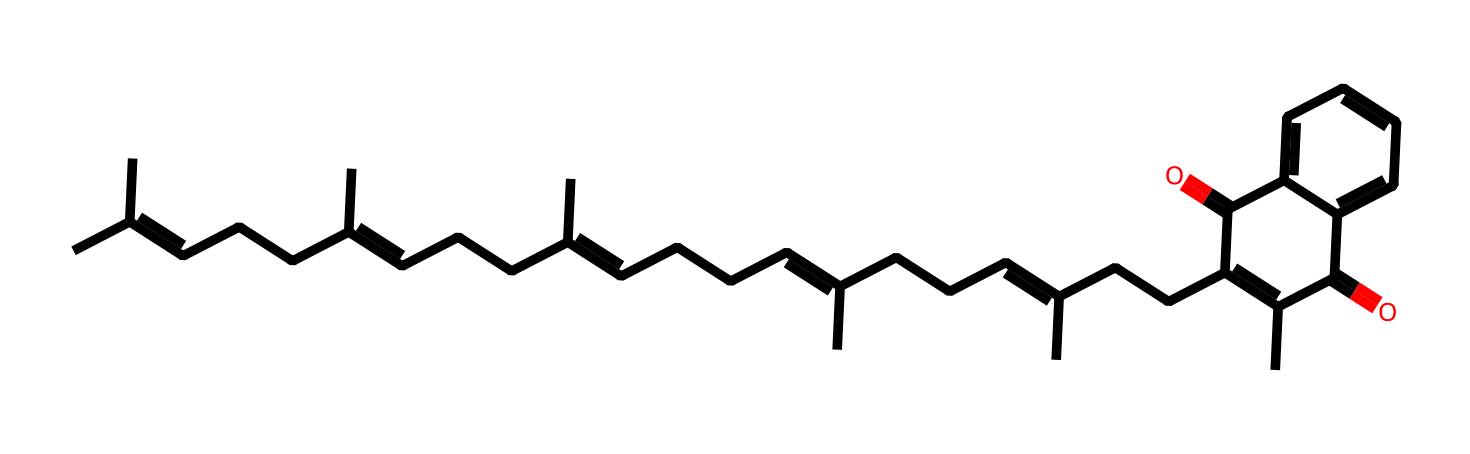What is the common name of this compound? The SMILES representation indicates a long-chain molecule with specific structures that corresponds to menaquinone, commonly known as vitamin K2.
Answer: vitamin K2 How many double bonds are present in the structure? By analyzing the SMILES, we identify multiple sections denoted by '=' that represent double bonds. Counting these instances shows there are five double bonds in the structure.
Answer: 5 What is the primary functional group present in vitamin K2? The structure includes a sequence of carbon chains and indicates multiple ring formations with ketone functionalities (C=O), showing that it predominantly features carbonyl groups as functional groups.
Answer: ketone How many carbon atoms are in the molecule? By breaking down the SMILES representation, we can count the total number of 'C' in the sequence. Including all branches indicates there are 27 carbon atoms present in the structure.
Answer: 27 Which part of the structure contributes to its vitamin classification? Vitamin K2 is classified as a vitamin due to the presence of the long isoprenoid side chain in addition to the cyclic structure, which is characteristic of vitamins involved in biological functions like blood coagulation.
Answer: isoprenoid side chain What type of chemical reaction would this compound likely participate in? The presence of double bonds and functional groups suggests that vitamin K2 could undergo oxidation-reduction reactions in biological systems, commonly associated with vital metabolic processes.
Answer: oxidation-reduction What role does vitamin K2 play in human health? Vitamin K2 is known for its role in calcium metabolism and bone health, vital for the proper functioning of proteins involved in these processes, thus contributing significantly to overall cardiovascular and bone health.
Answer: calcium metabolism 